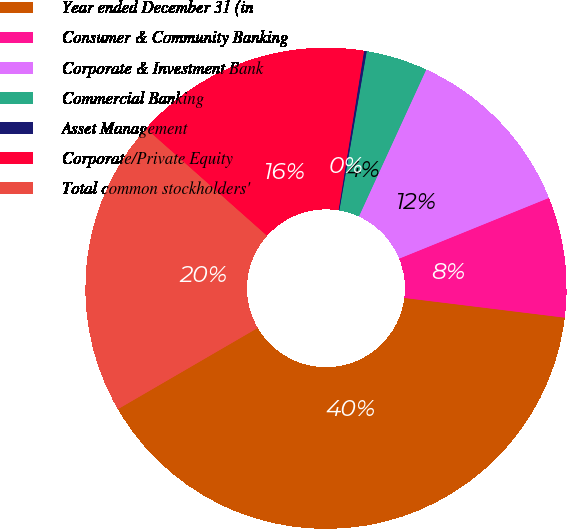Convert chart to OTSL. <chart><loc_0><loc_0><loc_500><loc_500><pie_chart><fcel>Year ended December 31 (in<fcel>Consumer & Community Banking<fcel>Corporate & Investment Bank<fcel>Commercial Banking<fcel>Asset Management<fcel>Corporate/Private Equity<fcel>Total common stockholders'<nl><fcel>39.68%<fcel>8.08%<fcel>12.03%<fcel>4.13%<fcel>0.18%<fcel>15.98%<fcel>19.93%<nl></chart> 